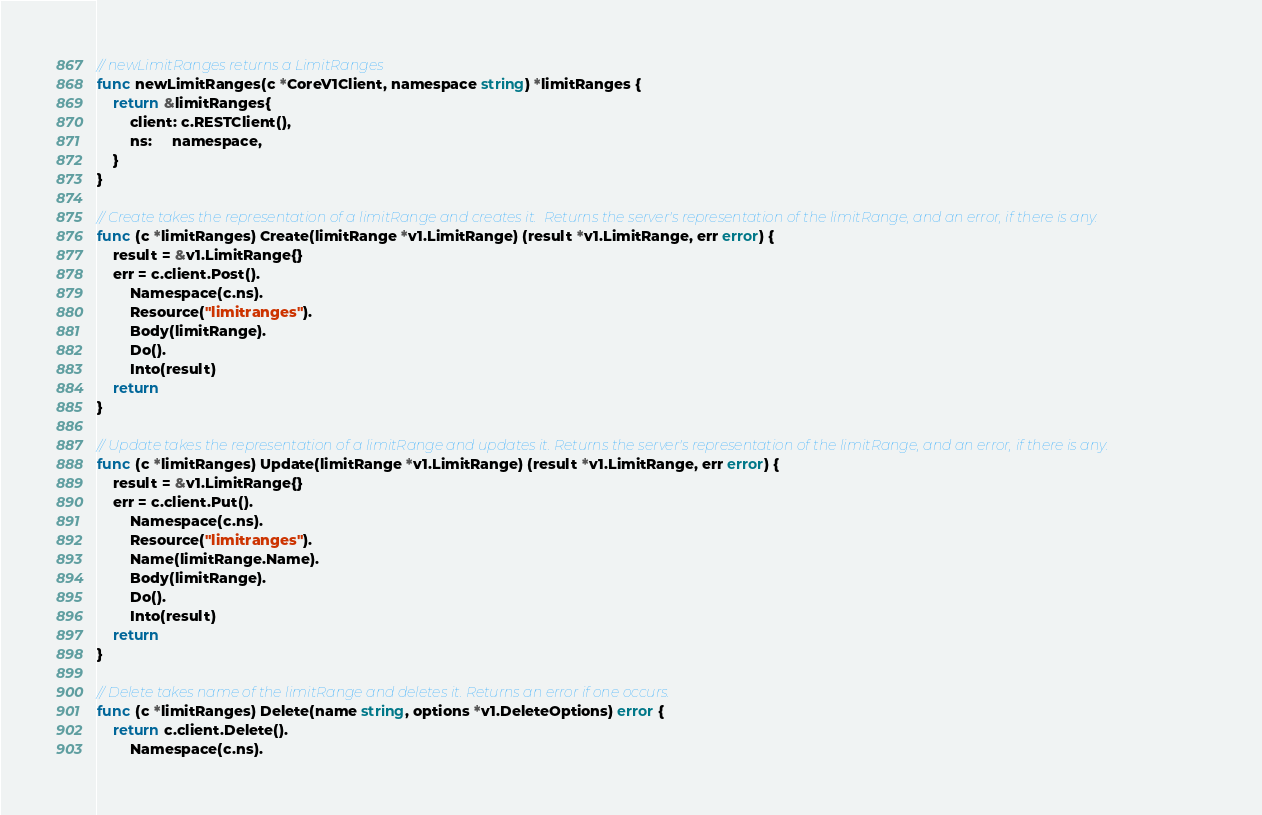<code> <loc_0><loc_0><loc_500><loc_500><_Go_>// newLimitRanges returns a LimitRanges
func newLimitRanges(c *CoreV1Client, namespace string) *limitRanges {
	return &limitRanges{
		client: c.RESTClient(),
		ns:     namespace,
	}
}

// Create takes the representation of a limitRange and creates it.  Returns the server's representation of the limitRange, and an error, if there is any.
func (c *limitRanges) Create(limitRange *v1.LimitRange) (result *v1.LimitRange, err error) {
	result = &v1.LimitRange{}
	err = c.client.Post().
		Namespace(c.ns).
		Resource("limitranges").
		Body(limitRange).
		Do().
		Into(result)
	return
}

// Update takes the representation of a limitRange and updates it. Returns the server's representation of the limitRange, and an error, if there is any.
func (c *limitRanges) Update(limitRange *v1.LimitRange) (result *v1.LimitRange, err error) {
	result = &v1.LimitRange{}
	err = c.client.Put().
		Namespace(c.ns).
		Resource("limitranges").
		Name(limitRange.Name).
		Body(limitRange).
		Do().
		Into(result)
	return
}

// Delete takes name of the limitRange and deletes it. Returns an error if one occurs.
func (c *limitRanges) Delete(name string, options *v1.DeleteOptions) error {
	return c.client.Delete().
		Namespace(c.ns).</code> 